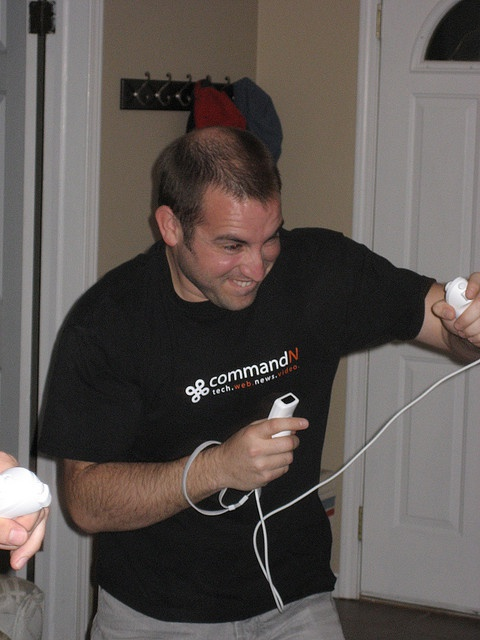Describe the objects in this image and their specific colors. I can see people in gray, black, and maroon tones, remote in gray, white, darkgray, and pink tones, remote in gray, lightgray, and darkgray tones, and remote in gray, lightgray, darkgray, and black tones in this image. 